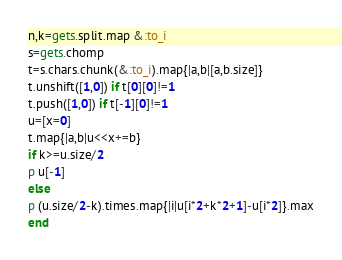<code> <loc_0><loc_0><loc_500><loc_500><_Ruby_>n,k=gets.split.map &:to_i
s=gets.chomp
t=s.chars.chunk(&:to_i).map{|a,b|[a,b.size]}
t.unshift([1,0]) if t[0][0]!=1
t.push([1,0]) if t[-1][0]!=1
u=[x=0]
t.map{|a,b|u<<x+=b}
if k>=u.size/2
p u[-1]
else
p (u.size/2-k).times.map{|i|u[i*2+k*2+1]-u[i*2]}.max
end</code> 